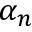<formula> <loc_0><loc_0><loc_500><loc_500>\alpha _ { n }</formula> 